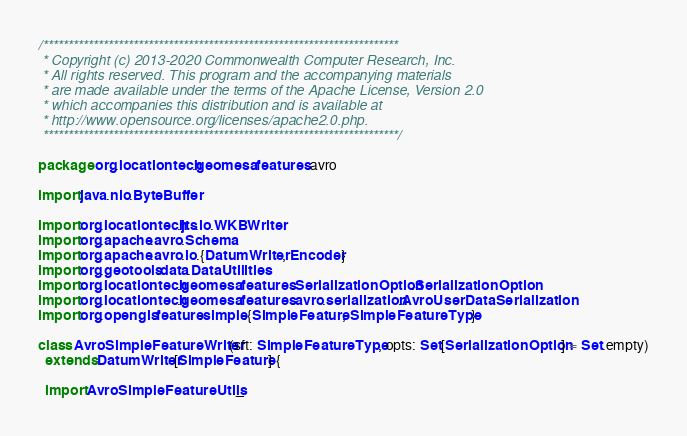Convert code to text. <code><loc_0><loc_0><loc_500><loc_500><_Scala_>/***********************************************************************
 * Copyright (c) 2013-2020 Commonwealth Computer Research, Inc.
 * All rights reserved. This program and the accompanying materials
 * are made available under the terms of the Apache License, Version 2.0
 * which accompanies this distribution and is available at
 * http://www.opensource.org/licenses/apache2.0.php.
 ***********************************************************************/

package org.locationtech.geomesa.features.avro

import java.nio.ByteBuffer

import org.locationtech.jts.io.WKBWriter
import org.apache.avro.Schema
import org.apache.avro.io.{DatumWriter, Encoder}
import org.geotools.data.DataUtilities
import org.locationtech.geomesa.features.SerializationOption.SerializationOption
import org.locationtech.geomesa.features.avro.serialization.AvroUserDataSerialization
import org.opengis.feature.simple.{SimpleFeature, SimpleFeatureType}

class AvroSimpleFeatureWriter(sft: SimpleFeatureType, opts: Set[SerializationOption] = Set.empty)
  extends DatumWriter[SimpleFeature] {

  import AvroSimpleFeatureUtils._
</code> 